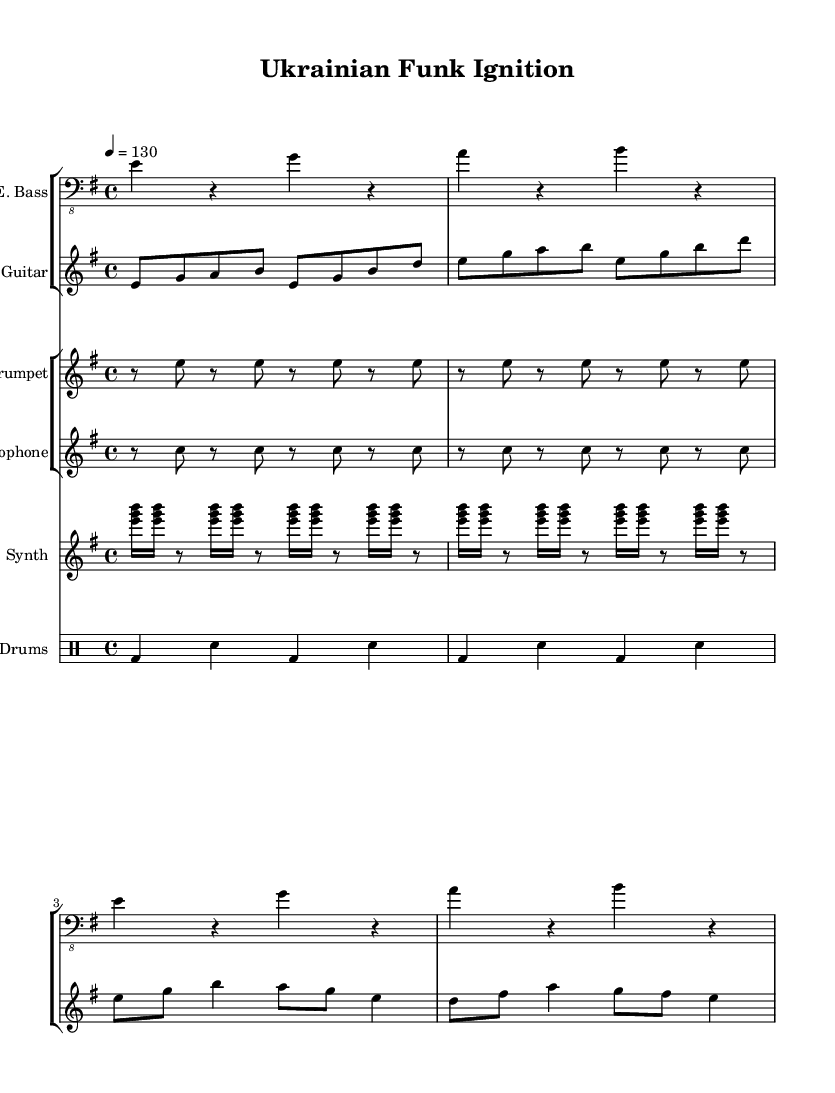What is the key signature of this music? The key signature is E minor, which has one sharp (F#). This can be determined by looking at the beginning of the staff where the key signature is indicated.
Answer: E minor What is the time signature of this piece? The time signature is 4/4, indicated at the beginning of the music. This means there are four beats in each measure and the quarter note gets one beat.
Answer: 4/4 What is the tempo marking for this composition? The tempo marking is 130 beats per minute, indicated by the number "4 = 130." This shows the pace of the music, specifically how many beats are played in one minute.
Answer: 130 How many measures does the first section contain? The first section of the music has four measures as seen in the electric bass part, which contains four distinct groupings of notes. Each grouping is separated by a bar line indicating a measure.
Answer: 4 What unique instrument is used in this piece that is characteristic of Funk music? The synthesizer is used in this composition, which is typical for Funk. The presence of synthesizers often adds a modern and electronic edge to the Funk genre, integrating catchy riffs and textures.
Answer: Synthesizer How is the rhythm pattern described in the drum part? The drum pattern consists of a bass drum followed by a snare drum, creating a standard backbeat which is characteristic of Funk rhythms, typically emphasizing the second and fourth beats.
Answer: Backbeat 